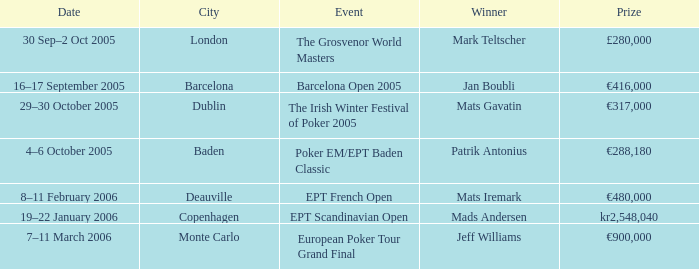What event did Mark Teltscher win? The Grosvenor World Masters. Can you give me this table as a dict? {'header': ['Date', 'City', 'Event', 'Winner', 'Prize'], 'rows': [['30 Sep–2 Oct 2005', 'London', 'The Grosvenor World Masters', 'Mark Teltscher', '£280,000'], ['16–17 September 2005', 'Barcelona', 'Barcelona Open 2005', 'Jan Boubli', '€416,000'], ['29–30 October 2005', 'Dublin', 'The Irish Winter Festival of Poker 2005', 'Mats Gavatin', '€317,000'], ['4–6 October 2005', 'Baden', 'Poker EM/EPT Baden Classic', 'Patrik Antonius', '€288,180'], ['8–11 February 2006', 'Deauville', 'EPT French Open', 'Mats Iremark', '€480,000'], ['19–22 January 2006', 'Copenhagen', 'EPT Scandinavian Open', 'Mads Andersen', 'kr2,548,040'], ['7–11 March 2006', 'Monte Carlo', 'European Poker Tour Grand Final', 'Jeff Williams', '€900,000']]} 